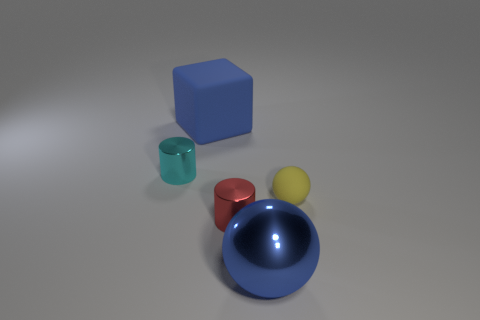Is the color of the large metal sphere the same as the cube?
Your answer should be very brief. Yes. There is a small shiny object in front of the small cylinder behind the tiny rubber ball; what is its shape?
Ensure brevity in your answer.  Cylinder. Is the number of blue spheres behind the big blue metal ball less than the number of metal cylinders that are to the left of the block?
Keep it short and to the point. Yes. What is the color of the other thing that is the same shape as the yellow thing?
Offer a terse response. Blue. How many things are to the left of the yellow rubber sphere and behind the big blue shiny object?
Your answer should be compact. 3. Is the number of shiny cylinders that are left of the tiny red shiny cylinder greater than the number of small matte balls that are to the left of the large blue shiny thing?
Offer a terse response. Yes. The cyan thing has what size?
Offer a very short reply. Small. Are there any other tiny things that have the same shape as the tiny red metal thing?
Your response must be concise. Yes. There is a small matte object; does it have the same shape as the thing in front of the tiny red metal object?
Ensure brevity in your answer.  Yes. What is the size of the metallic thing that is both to the left of the large blue shiny object and right of the cube?
Your response must be concise. Small. 